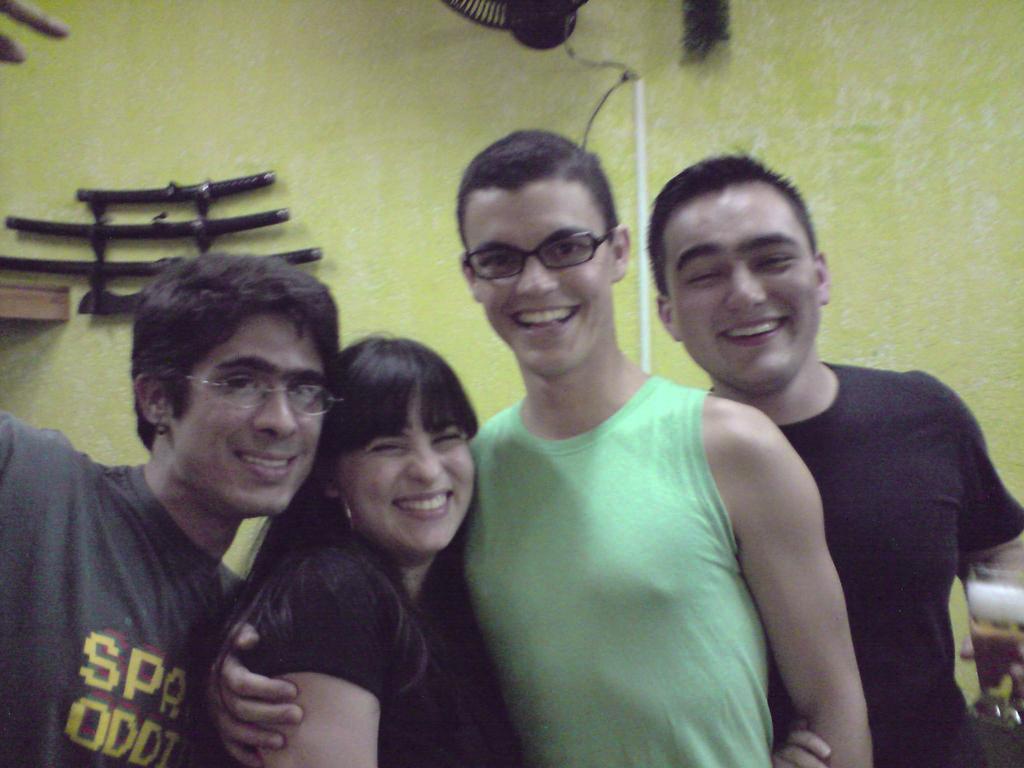In one or two sentences, can you explain what this image depicts? In the picture we can see three men and one woman are standing together and smiling, woman is in a black dress and behind them, we can see a wall with some things placed in it. 